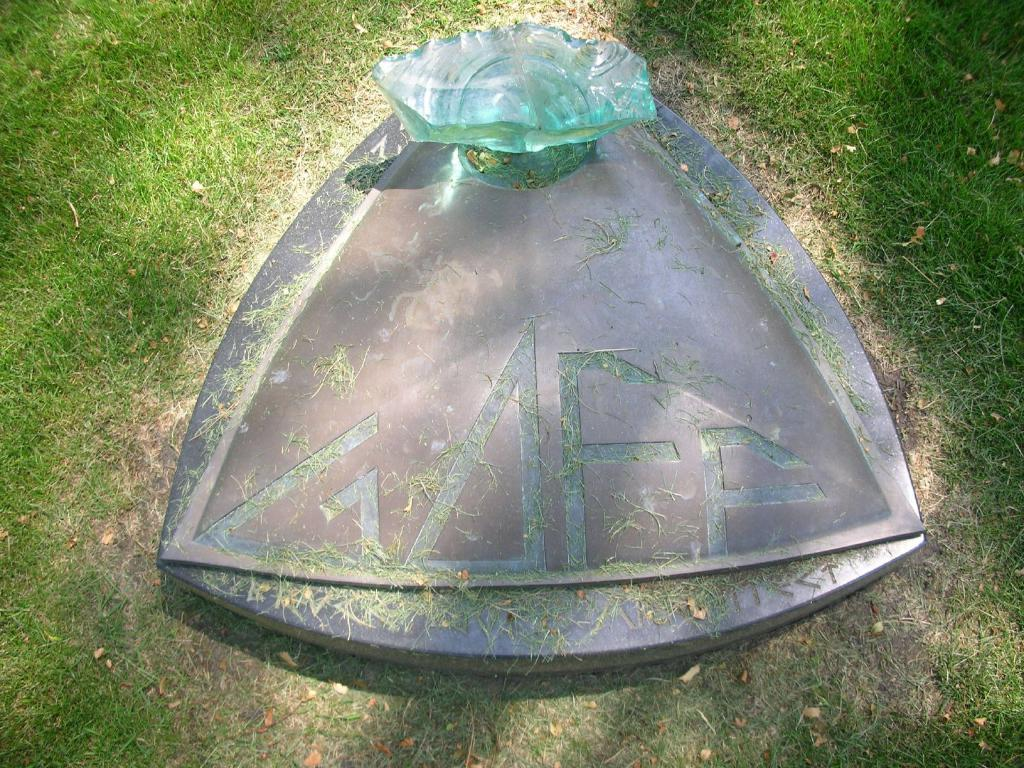What type of object can be seen in the image? There is a stone in the image. What type of vegetation is present in the image? There is grass in the image. How many stars can be seen kissing in the image? There are no stars or kissing depicted in the image; it features a stone and grass. 